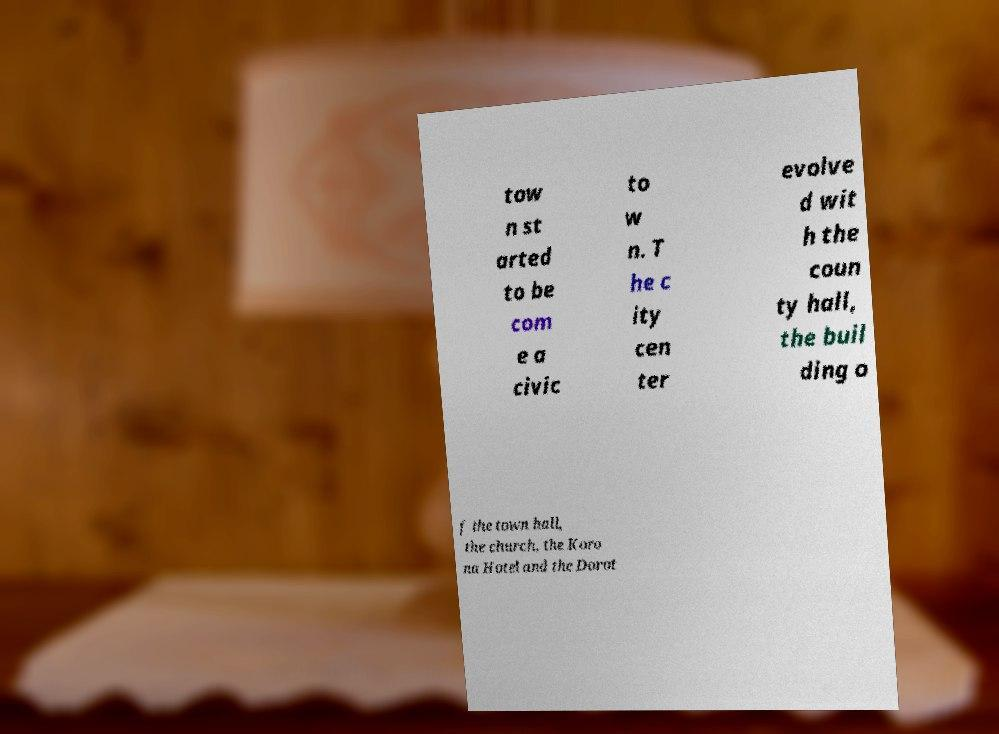Can you read and provide the text displayed in the image?This photo seems to have some interesting text. Can you extract and type it out for me? tow n st arted to be com e a civic to w n. T he c ity cen ter evolve d wit h the coun ty hall, the buil ding o f the town hall, the church, the Koro na Hotel and the Dorot 